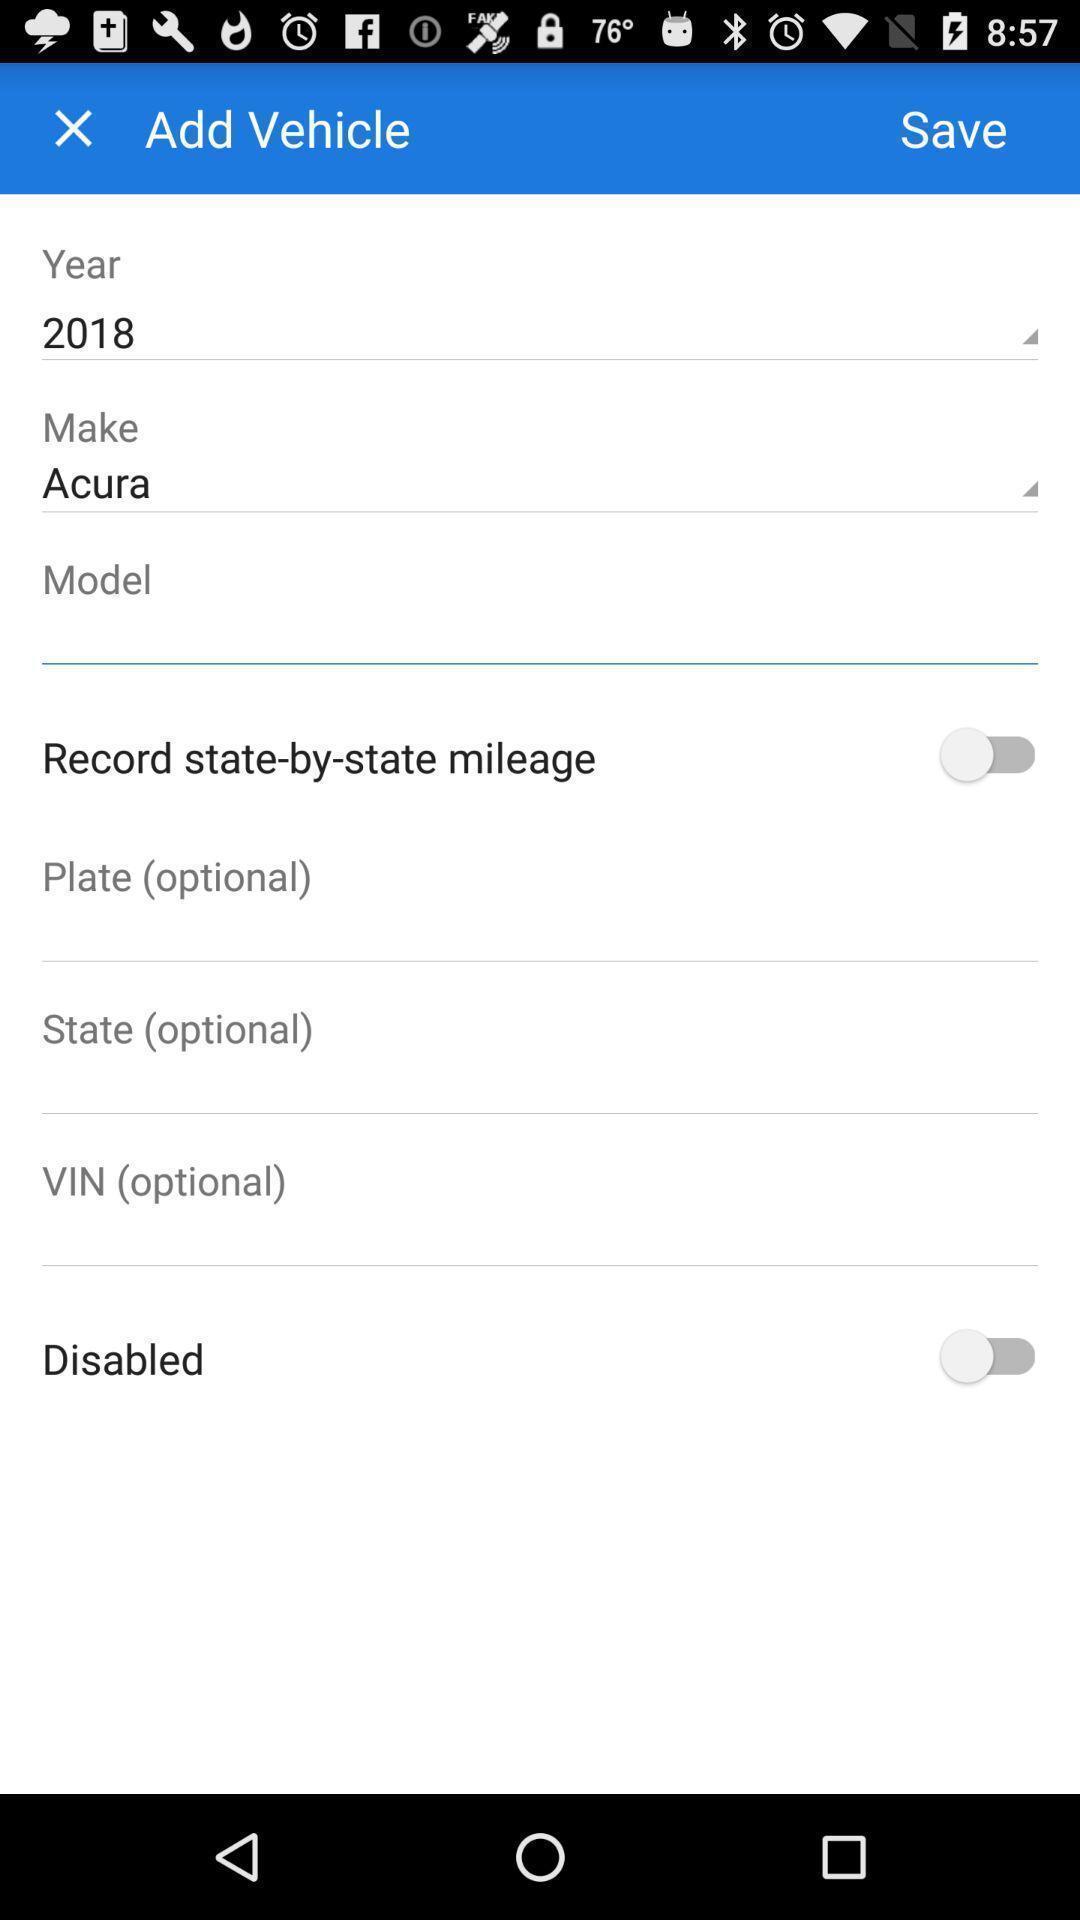What can you discern from this picture? Screen displaying multiple vehicle options. 